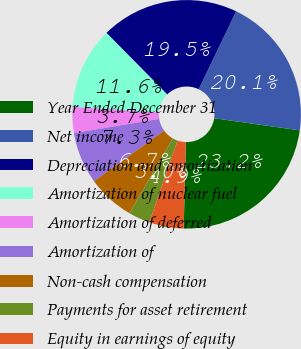Convert chart to OTSL. <chart><loc_0><loc_0><loc_500><loc_500><pie_chart><fcel>Year Ended December 31<fcel>Net income<fcel>Depreciation and amortization<fcel>Amortization of nuclear fuel<fcel>Amortization of deferred<fcel>Amortization of<fcel>Non-cash compensation<fcel>Payments for asset retirement<fcel>Equity in earnings of equity<nl><fcel>23.17%<fcel>20.12%<fcel>19.51%<fcel>11.59%<fcel>3.66%<fcel>7.32%<fcel>6.71%<fcel>3.05%<fcel>4.88%<nl></chart> 